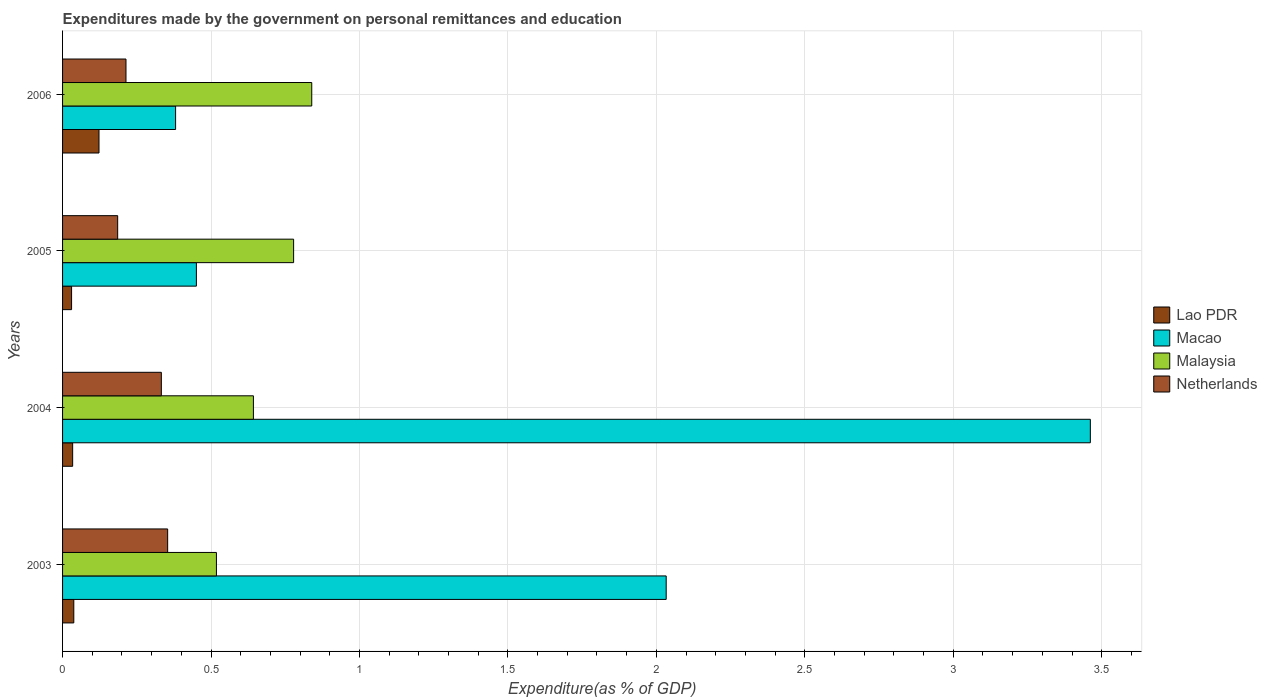How many different coloured bars are there?
Offer a very short reply. 4. How many groups of bars are there?
Provide a succinct answer. 4. Are the number of bars on each tick of the Y-axis equal?
Your answer should be very brief. Yes. What is the label of the 2nd group of bars from the top?
Offer a terse response. 2005. In how many cases, is the number of bars for a given year not equal to the number of legend labels?
Your answer should be very brief. 0. What is the expenditures made by the government on personal remittances and education in Malaysia in 2003?
Make the answer very short. 0.52. Across all years, what is the maximum expenditures made by the government on personal remittances and education in Netherlands?
Your response must be concise. 0.35. Across all years, what is the minimum expenditures made by the government on personal remittances and education in Malaysia?
Your answer should be compact. 0.52. In which year was the expenditures made by the government on personal remittances and education in Netherlands maximum?
Your answer should be compact. 2003. In which year was the expenditures made by the government on personal remittances and education in Malaysia minimum?
Give a very brief answer. 2003. What is the total expenditures made by the government on personal remittances and education in Malaysia in the graph?
Keep it short and to the point. 2.78. What is the difference between the expenditures made by the government on personal remittances and education in Malaysia in 2004 and that in 2006?
Make the answer very short. -0.2. What is the difference between the expenditures made by the government on personal remittances and education in Lao PDR in 2006 and the expenditures made by the government on personal remittances and education in Macao in 2003?
Offer a terse response. -1.91. What is the average expenditures made by the government on personal remittances and education in Lao PDR per year?
Ensure brevity in your answer.  0.06. In the year 2004, what is the difference between the expenditures made by the government on personal remittances and education in Macao and expenditures made by the government on personal remittances and education in Malaysia?
Make the answer very short. 2.82. In how many years, is the expenditures made by the government on personal remittances and education in Malaysia greater than 3.5 %?
Make the answer very short. 0. What is the ratio of the expenditures made by the government on personal remittances and education in Malaysia in 2003 to that in 2006?
Your answer should be compact. 0.62. Is the expenditures made by the government on personal remittances and education in Netherlands in 2003 less than that in 2004?
Keep it short and to the point. No. What is the difference between the highest and the second highest expenditures made by the government on personal remittances and education in Macao?
Offer a terse response. 1.43. What is the difference between the highest and the lowest expenditures made by the government on personal remittances and education in Netherlands?
Ensure brevity in your answer.  0.17. Is the sum of the expenditures made by the government on personal remittances and education in Lao PDR in 2003 and 2006 greater than the maximum expenditures made by the government on personal remittances and education in Netherlands across all years?
Your answer should be compact. No. Is it the case that in every year, the sum of the expenditures made by the government on personal remittances and education in Malaysia and expenditures made by the government on personal remittances and education in Lao PDR is greater than the sum of expenditures made by the government on personal remittances and education in Macao and expenditures made by the government on personal remittances and education in Netherlands?
Provide a short and direct response. No. What does the 3rd bar from the top in 2005 represents?
Offer a very short reply. Macao. What does the 1st bar from the bottom in 2006 represents?
Offer a terse response. Lao PDR. How many years are there in the graph?
Your response must be concise. 4. What is the difference between two consecutive major ticks on the X-axis?
Ensure brevity in your answer.  0.5. Are the values on the major ticks of X-axis written in scientific E-notation?
Your answer should be compact. No. Does the graph contain any zero values?
Ensure brevity in your answer.  No. Does the graph contain grids?
Your answer should be very brief. Yes. What is the title of the graph?
Make the answer very short. Expenditures made by the government on personal remittances and education. What is the label or title of the X-axis?
Give a very brief answer. Expenditure(as % of GDP). What is the label or title of the Y-axis?
Your response must be concise. Years. What is the Expenditure(as % of GDP) of Lao PDR in 2003?
Provide a succinct answer. 0.04. What is the Expenditure(as % of GDP) in Macao in 2003?
Provide a succinct answer. 2.03. What is the Expenditure(as % of GDP) of Malaysia in 2003?
Provide a succinct answer. 0.52. What is the Expenditure(as % of GDP) in Netherlands in 2003?
Your answer should be very brief. 0.35. What is the Expenditure(as % of GDP) in Lao PDR in 2004?
Offer a very short reply. 0.03. What is the Expenditure(as % of GDP) in Macao in 2004?
Ensure brevity in your answer.  3.46. What is the Expenditure(as % of GDP) of Malaysia in 2004?
Provide a succinct answer. 0.64. What is the Expenditure(as % of GDP) in Netherlands in 2004?
Provide a short and direct response. 0.33. What is the Expenditure(as % of GDP) of Lao PDR in 2005?
Your response must be concise. 0.03. What is the Expenditure(as % of GDP) of Macao in 2005?
Provide a succinct answer. 0.45. What is the Expenditure(as % of GDP) of Malaysia in 2005?
Keep it short and to the point. 0.78. What is the Expenditure(as % of GDP) of Netherlands in 2005?
Ensure brevity in your answer.  0.19. What is the Expenditure(as % of GDP) of Lao PDR in 2006?
Your answer should be compact. 0.12. What is the Expenditure(as % of GDP) in Macao in 2006?
Make the answer very short. 0.38. What is the Expenditure(as % of GDP) in Malaysia in 2006?
Offer a terse response. 0.84. What is the Expenditure(as % of GDP) in Netherlands in 2006?
Give a very brief answer. 0.21. Across all years, what is the maximum Expenditure(as % of GDP) of Lao PDR?
Ensure brevity in your answer.  0.12. Across all years, what is the maximum Expenditure(as % of GDP) in Macao?
Keep it short and to the point. 3.46. Across all years, what is the maximum Expenditure(as % of GDP) in Malaysia?
Make the answer very short. 0.84. Across all years, what is the maximum Expenditure(as % of GDP) in Netherlands?
Give a very brief answer. 0.35. Across all years, what is the minimum Expenditure(as % of GDP) in Lao PDR?
Your answer should be very brief. 0.03. Across all years, what is the minimum Expenditure(as % of GDP) of Macao?
Ensure brevity in your answer.  0.38. Across all years, what is the minimum Expenditure(as % of GDP) of Malaysia?
Make the answer very short. 0.52. Across all years, what is the minimum Expenditure(as % of GDP) in Netherlands?
Your answer should be compact. 0.19. What is the total Expenditure(as % of GDP) in Lao PDR in the graph?
Offer a terse response. 0.22. What is the total Expenditure(as % of GDP) in Macao in the graph?
Your answer should be compact. 6.33. What is the total Expenditure(as % of GDP) in Malaysia in the graph?
Your answer should be very brief. 2.78. What is the total Expenditure(as % of GDP) of Netherlands in the graph?
Keep it short and to the point. 1.09. What is the difference between the Expenditure(as % of GDP) in Lao PDR in 2003 and that in 2004?
Your response must be concise. 0. What is the difference between the Expenditure(as % of GDP) in Macao in 2003 and that in 2004?
Your answer should be compact. -1.43. What is the difference between the Expenditure(as % of GDP) in Malaysia in 2003 and that in 2004?
Give a very brief answer. -0.12. What is the difference between the Expenditure(as % of GDP) of Netherlands in 2003 and that in 2004?
Provide a short and direct response. 0.02. What is the difference between the Expenditure(as % of GDP) of Lao PDR in 2003 and that in 2005?
Make the answer very short. 0.01. What is the difference between the Expenditure(as % of GDP) of Macao in 2003 and that in 2005?
Keep it short and to the point. 1.58. What is the difference between the Expenditure(as % of GDP) in Malaysia in 2003 and that in 2005?
Your answer should be compact. -0.26. What is the difference between the Expenditure(as % of GDP) in Netherlands in 2003 and that in 2005?
Your response must be concise. 0.17. What is the difference between the Expenditure(as % of GDP) of Lao PDR in 2003 and that in 2006?
Offer a very short reply. -0.08. What is the difference between the Expenditure(as % of GDP) in Macao in 2003 and that in 2006?
Provide a short and direct response. 1.65. What is the difference between the Expenditure(as % of GDP) in Malaysia in 2003 and that in 2006?
Your response must be concise. -0.32. What is the difference between the Expenditure(as % of GDP) of Netherlands in 2003 and that in 2006?
Offer a very short reply. 0.14. What is the difference between the Expenditure(as % of GDP) in Lao PDR in 2004 and that in 2005?
Provide a succinct answer. 0. What is the difference between the Expenditure(as % of GDP) of Macao in 2004 and that in 2005?
Provide a succinct answer. 3.01. What is the difference between the Expenditure(as % of GDP) in Malaysia in 2004 and that in 2005?
Offer a terse response. -0.14. What is the difference between the Expenditure(as % of GDP) of Netherlands in 2004 and that in 2005?
Your response must be concise. 0.15. What is the difference between the Expenditure(as % of GDP) in Lao PDR in 2004 and that in 2006?
Ensure brevity in your answer.  -0.09. What is the difference between the Expenditure(as % of GDP) in Macao in 2004 and that in 2006?
Your answer should be very brief. 3.08. What is the difference between the Expenditure(as % of GDP) of Malaysia in 2004 and that in 2006?
Provide a short and direct response. -0.2. What is the difference between the Expenditure(as % of GDP) in Netherlands in 2004 and that in 2006?
Your answer should be compact. 0.12. What is the difference between the Expenditure(as % of GDP) of Lao PDR in 2005 and that in 2006?
Keep it short and to the point. -0.09. What is the difference between the Expenditure(as % of GDP) in Macao in 2005 and that in 2006?
Your response must be concise. 0.07. What is the difference between the Expenditure(as % of GDP) of Malaysia in 2005 and that in 2006?
Your response must be concise. -0.06. What is the difference between the Expenditure(as % of GDP) in Netherlands in 2005 and that in 2006?
Offer a terse response. -0.03. What is the difference between the Expenditure(as % of GDP) in Lao PDR in 2003 and the Expenditure(as % of GDP) in Macao in 2004?
Your response must be concise. -3.42. What is the difference between the Expenditure(as % of GDP) of Lao PDR in 2003 and the Expenditure(as % of GDP) of Malaysia in 2004?
Ensure brevity in your answer.  -0.6. What is the difference between the Expenditure(as % of GDP) in Lao PDR in 2003 and the Expenditure(as % of GDP) in Netherlands in 2004?
Offer a terse response. -0.29. What is the difference between the Expenditure(as % of GDP) in Macao in 2003 and the Expenditure(as % of GDP) in Malaysia in 2004?
Ensure brevity in your answer.  1.39. What is the difference between the Expenditure(as % of GDP) of Macao in 2003 and the Expenditure(as % of GDP) of Netherlands in 2004?
Ensure brevity in your answer.  1.7. What is the difference between the Expenditure(as % of GDP) of Malaysia in 2003 and the Expenditure(as % of GDP) of Netherlands in 2004?
Make the answer very short. 0.19. What is the difference between the Expenditure(as % of GDP) of Lao PDR in 2003 and the Expenditure(as % of GDP) of Macao in 2005?
Your answer should be compact. -0.41. What is the difference between the Expenditure(as % of GDP) in Lao PDR in 2003 and the Expenditure(as % of GDP) in Malaysia in 2005?
Your answer should be very brief. -0.74. What is the difference between the Expenditure(as % of GDP) in Lao PDR in 2003 and the Expenditure(as % of GDP) in Netherlands in 2005?
Provide a succinct answer. -0.15. What is the difference between the Expenditure(as % of GDP) in Macao in 2003 and the Expenditure(as % of GDP) in Malaysia in 2005?
Give a very brief answer. 1.25. What is the difference between the Expenditure(as % of GDP) in Macao in 2003 and the Expenditure(as % of GDP) in Netherlands in 2005?
Keep it short and to the point. 1.85. What is the difference between the Expenditure(as % of GDP) of Malaysia in 2003 and the Expenditure(as % of GDP) of Netherlands in 2005?
Offer a very short reply. 0.33. What is the difference between the Expenditure(as % of GDP) in Lao PDR in 2003 and the Expenditure(as % of GDP) in Macao in 2006?
Offer a very short reply. -0.34. What is the difference between the Expenditure(as % of GDP) in Lao PDR in 2003 and the Expenditure(as % of GDP) in Malaysia in 2006?
Offer a terse response. -0.8. What is the difference between the Expenditure(as % of GDP) in Lao PDR in 2003 and the Expenditure(as % of GDP) in Netherlands in 2006?
Provide a short and direct response. -0.18. What is the difference between the Expenditure(as % of GDP) in Macao in 2003 and the Expenditure(as % of GDP) in Malaysia in 2006?
Provide a succinct answer. 1.19. What is the difference between the Expenditure(as % of GDP) of Macao in 2003 and the Expenditure(as % of GDP) of Netherlands in 2006?
Offer a terse response. 1.82. What is the difference between the Expenditure(as % of GDP) of Malaysia in 2003 and the Expenditure(as % of GDP) of Netherlands in 2006?
Offer a very short reply. 0.3. What is the difference between the Expenditure(as % of GDP) of Lao PDR in 2004 and the Expenditure(as % of GDP) of Macao in 2005?
Provide a short and direct response. -0.42. What is the difference between the Expenditure(as % of GDP) in Lao PDR in 2004 and the Expenditure(as % of GDP) in Malaysia in 2005?
Your answer should be very brief. -0.74. What is the difference between the Expenditure(as % of GDP) in Lao PDR in 2004 and the Expenditure(as % of GDP) in Netherlands in 2005?
Your answer should be very brief. -0.15. What is the difference between the Expenditure(as % of GDP) in Macao in 2004 and the Expenditure(as % of GDP) in Malaysia in 2005?
Your answer should be very brief. 2.68. What is the difference between the Expenditure(as % of GDP) in Macao in 2004 and the Expenditure(as % of GDP) in Netherlands in 2005?
Provide a short and direct response. 3.28. What is the difference between the Expenditure(as % of GDP) in Malaysia in 2004 and the Expenditure(as % of GDP) in Netherlands in 2005?
Your answer should be very brief. 0.46. What is the difference between the Expenditure(as % of GDP) in Lao PDR in 2004 and the Expenditure(as % of GDP) in Macao in 2006?
Keep it short and to the point. -0.35. What is the difference between the Expenditure(as % of GDP) in Lao PDR in 2004 and the Expenditure(as % of GDP) in Malaysia in 2006?
Provide a succinct answer. -0.81. What is the difference between the Expenditure(as % of GDP) of Lao PDR in 2004 and the Expenditure(as % of GDP) of Netherlands in 2006?
Offer a very short reply. -0.18. What is the difference between the Expenditure(as % of GDP) in Macao in 2004 and the Expenditure(as % of GDP) in Malaysia in 2006?
Offer a terse response. 2.62. What is the difference between the Expenditure(as % of GDP) of Macao in 2004 and the Expenditure(as % of GDP) of Netherlands in 2006?
Give a very brief answer. 3.25. What is the difference between the Expenditure(as % of GDP) in Malaysia in 2004 and the Expenditure(as % of GDP) in Netherlands in 2006?
Your response must be concise. 0.43. What is the difference between the Expenditure(as % of GDP) in Lao PDR in 2005 and the Expenditure(as % of GDP) in Macao in 2006?
Offer a terse response. -0.35. What is the difference between the Expenditure(as % of GDP) of Lao PDR in 2005 and the Expenditure(as % of GDP) of Malaysia in 2006?
Offer a very short reply. -0.81. What is the difference between the Expenditure(as % of GDP) of Lao PDR in 2005 and the Expenditure(as % of GDP) of Netherlands in 2006?
Offer a terse response. -0.18. What is the difference between the Expenditure(as % of GDP) in Macao in 2005 and the Expenditure(as % of GDP) in Malaysia in 2006?
Ensure brevity in your answer.  -0.39. What is the difference between the Expenditure(as % of GDP) of Macao in 2005 and the Expenditure(as % of GDP) of Netherlands in 2006?
Provide a short and direct response. 0.24. What is the difference between the Expenditure(as % of GDP) in Malaysia in 2005 and the Expenditure(as % of GDP) in Netherlands in 2006?
Make the answer very short. 0.56. What is the average Expenditure(as % of GDP) of Lao PDR per year?
Make the answer very short. 0.06. What is the average Expenditure(as % of GDP) of Macao per year?
Offer a terse response. 1.58. What is the average Expenditure(as % of GDP) in Malaysia per year?
Offer a terse response. 0.69. What is the average Expenditure(as % of GDP) of Netherlands per year?
Offer a terse response. 0.27. In the year 2003, what is the difference between the Expenditure(as % of GDP) of Lao PDR and Expenditure(as % of GDP) of Macao?
Offer a very short reply. -2. In the year 2003, what is the difference between the Expenditure(as % of GDP) in Lao PDR and Expenditure(as % of GDP) in Malaysia?
Offer a very short reply. -0.48. In the year 2003, what is the difference between the Expenditure(as % of GDP) of Lao PDR and Expenditure(as % of GDP) of Netherlands?
Offer a very short reply. -0.32. In the year 2003, what is the difference between the Expenditure(as % of GDP) in Macao and Expenditure(as % of GDP) in Malaysia?
Provide a succinct answer. 1.51. In the year 2003, what is the difference between the Expenditure(as % of GDP) in Macao and Expenditure(as % of GDP) in Netherlands?
Provide a succinct answer. 1.68. In the year 2003, what is the difference between the Expenditure(as % of GDP) in Malaysia and Expenditure(as % of GDP) in Netherlands?
Keep it short and to the point. 0.16. In the year 2004, what is the difference between the Expenditure(as % of GDP) in Lao PDR and Expenditure(as % of GDP) in Macao?
Provide a succinct answer. -3.43. In the year 2004, what is the difference between the Expenditure(as % of GDP) of Lao PDR and Expenditure(as % of GDP) of Malaysia?
Keep it short and to the point. -0.61. In the year 2004, what is the difference between the Expenditure(as % of GDP) in Lao PDR and Expenditure(as % of GDP) in Netherlands?
Offer a terse response. -0.3. In the year 2004, what is the difference between the Expenditure(as % of GDP) of Macao and Expenditure(as % of GDP) of Malaysia?
Offer a terse response. 2.82. In the year 2004, what is the difference between the Expenditure(as % of GDP) of Macao and Expenditure(as % of GDP) of Netherlands?
Ensure brevity in your answer.  3.13. In the year 2004, what is the difference between the Expenditure(as % of GDP) in Malaysia and Expenditure(as % of GDP) in Netherlands?
Make the answer very short. 0.31. In the year 2005, what is the difference between the Expenditure(as % of GDP) in Lao PDR and Expenditure(as % of GDP) in Macao?
Make the answer very short. -0.42. In the year 2005, what is the difference between the Expenditure(as % of GDP) of Lao PDR and Expenditure(as % of GDP) of Malaysia?
Offer a very short reply. -0.75. In the year 2005, what is the difference between the Expenditure(as % of GDP) in Lao PDR and Expenditure(as % of GDP) in Netherlands?
Offer a very short reply. -0.16. In the year 2005, what is the difference between the Expenditure(as % of GDP) in Macao and Expenditure(as % of GDP) in Malaysia?
Give a very brief answer. -0.33. In the year 2005, what is the difference between the Expenditure(as % of GDP) of Macao and Expenditure(as % of GDP) of Netherlands?
Your response must be concise. 0.27. In the year 2005, what is the difference between the Expenditure(as % of GDP) in Malaysia and Expenditure(as % of GDP) in Netherlands?
Your answer should be very brief. 0.59. In the year 2006, what is the difference between the Expenditure(as % of GDP) in Lao PDR and Expenditure(as % of GDP) in Macao?
Keep it short and to the point. -0.26. In the year 2006, what is the difference between the Expenditure(as % of GDP) of Lao PDR and Expenditure(as % of GDP) of Malaysia?
Keep it short and to the point. -0.72. In the year 2006, what is the difference between the Expenditure(as % of GDP) of Lao PDR and Expenditure(as % of GDP) of Netherlands?
Ensure brevity in your answer.  -0.09. In the year 2006, what is the difference between the Expenditure(as % of GDP) of Macao and Expenditure(as % of GDP) of Malaysia?
Make the answer very short. -0.46. In the year 2006, what is the difference between the Expenditure(as % of GDP) of Macao and Expenditure(as % of GDP) of Netherlands?
Give a very brief answer. 0.17. In the year 2006, what is the difference between the Expenditure(as % of GDP) in Malaysia and Expenditure(as % of GDP) in Netherlands?
Your answer should be very brief. 0.63. What is the ratio of the Expenditure(as % of GDP) in Lao PDR in 2003 to that in 2004?
Offer a very short reply. 1.11. What is the ratio of the Expenditure(as % of GDP) in Macao in 2003 to that in 2004?
Your answer should be very brief. 0.59. What is the ratio of the Expenditure(as % of GDP) of Malaysia in 2003 to that in 2004?
Ensure brevity in your answer.  0.81. What is the ratio of the Expenditure(as % of GDP) of Netherlands in 2003 to that in 2004?
Ensure brevity in your answer.  1.06. What is the ratio of the Expenditure(as % of GDP) of Lao PDR in 2003 to that in 2005?
Offer a terse response. 1.25. What is the ratio of the Expenditure(as % of GDP) in Macao in 2003 to that in 2005?
Ensure brevity in your answer.  4.51. What is the ratio of the Expenditure(as % of GDP) of Malaysia in 2003 to that in 2005?
Offer a terse response. 0.67. What is the ratio of the Expenditure(as % of GDP) of Netherlands in 2003 to that in 2005?
Your answer should be very brief. 1.91. What is the ratio of the Expenditure(as % of GDP) in Lao PDR in 2003 to that in 2006?
Give a very brief answer. 0.31. What is the ratio of the Expenditure(as % of GDP) of Macao in 2003 to that in 2006?
Provide a succinct answer. 5.34. What is the ratio of the Expenditure(as % of GDP) of Malaysia in 2003 to that in 2006?
Provide a short and direct response. 0.62. What is the ratio of the Expenditure(as % of GDP) in Netherlands in 2003 to that in 2006?
Keep it short and to the point. 1.66. What is the ratio of the Expenditure(as % of GDP) of Lao PDR in 2004 to that in 2005?
Provide a short and direct response. 1.12. What is the ratio of the Expenditure(as % of GDP) of Macao in 2004 to that in 2005?
Offer a very short reply. 7.68. What is the ratio of the Expenditure(as % of GDP) of Malaysia in 2004 to that in 2005?
Keep it short and to the point. 0.83. What is the ratio of the Expenditure(as % of GDP) in Netherlands in 2004 to that in 2005?
Provide a short and direct response. 1.79. What is the ratio of the Expenditure(as % of GDP) of Lao PDR in 2004 to that in 2006?
Make the answer very short. 0.28. What is the ratio of the Expenditure(as % of GDP) in Macao in 2004 to that in 2006?
Make the answer very short. 9.09. What is the ratio of the Expenditure(as % of GDP) of Malaysia in 2004 to that in 2006?
Give a very brief answer. 0.77. What is the ratio of the Expenditure(as % of GDP) in Netherlands in 2004 to that in 2006?
Make the answer very short. 1.56. What is the ratio of the Expenditure(as % of GDP) of Lao PDR in 2005 to that in 2006?
Your answer should be compact. 0.25. What is the ratio of the Expenditure(as % of GDP) in Macao in 2005 to that in 2006?
Offer a very short reply. 1.18. What is the ratio of the Expenditure(as % of GDP) in Malaysia in 2005 to that in 2006?
Keep it short and to the point. 0.93. What is the ratio of the Expenditure(as % of GDP) of Netherlands in 2005 to that in 2006?
Give a very brief answer. 0.87. What is the difference between the highest and the second highest Expenditure(as % of GDP) in Lao PDR?
Keep it short and to the point. 0.08. What is the difference between the highest and the second highest Expenditure(as % of GDP) in Macao?
Your answer should be very brief. 1.43. What is the difference between the highest and the second highest Expenditure(as % of GDP) in Malaysia?
Provide a succinct answer. 0.06. What is the difference between the highest and the second highest Expenditure(as % of GDP) of Netherlands?
Your answer should be compact. 0.02. What is the difference between the highest and the lowest Expenditure(as % of GDP) in Lao PDR?
Your answer should be very brief. 0.09. What is the difference between the highest and the lowest Expenditure(as % of GDP) in Macao?
Offer a very short reply. 3.08. What is the difference between the highest and the lowest Expenditure(as % of GDP) of Malaysia?
Provide a succinct answer. 0.32. What is the difference between the highest and the lowest Expenditure(as % of GDP) in Netherlands?
Provide a succinct answer. 0.17. 